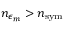<formula> <loc_0><loc_0><loc_500><loc_500>n _ { \epsilon _ { m } } > n _ { s y m }</formula> 